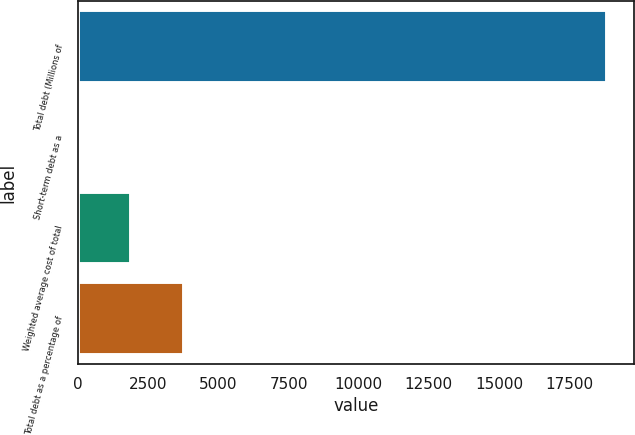Convert chart. <chart><loc_0><loc_0><loc_500><loc_500><bar_chart><fcel>Total debt (Millions of<fcel>Short-term debt as a<fcel>Weighted average cost of total<fcel>Total debt as a percentage of<nl><fcel>18870<fcel>1.1<fcel>1887.99<fcel>3774.88<nl></chart> 